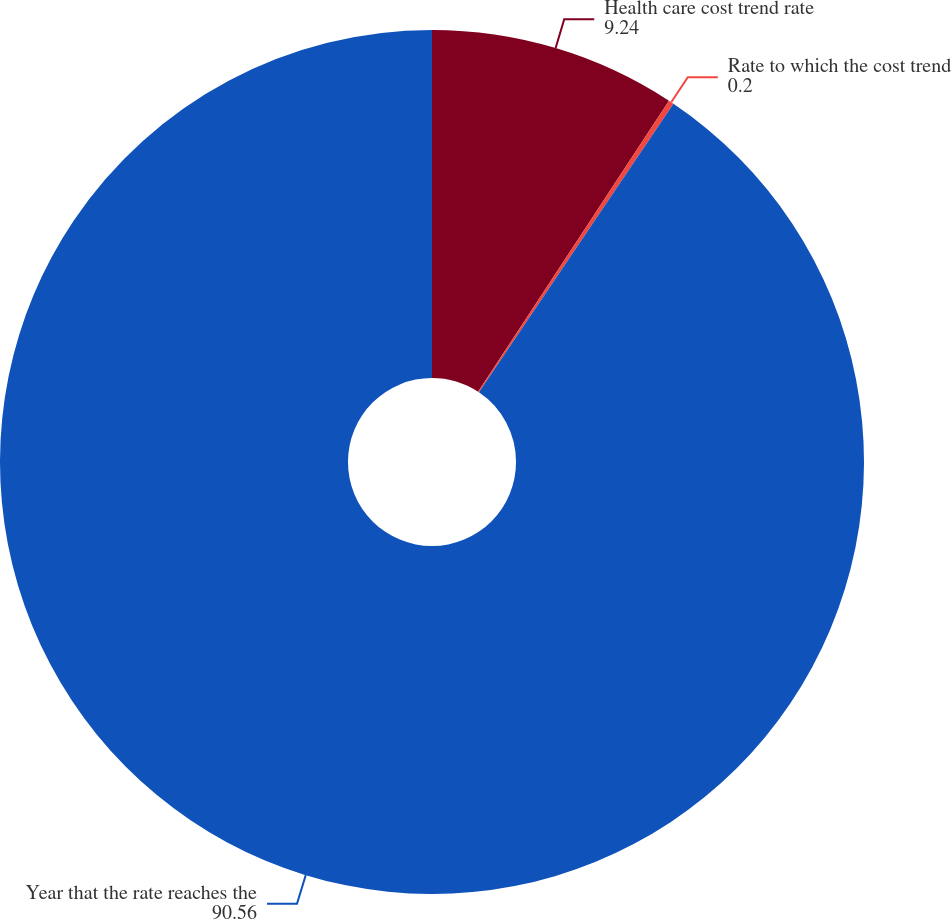Convert chart. <chart><loc_0><loc_0><loc_500><loc_500><pie_chart><fcel>Health care cost trend rate<fcel>Rate to which the cost trend<fcel>Year that the rate reaches the<nl><fcel>9.24%<fcel>0.2%<fcel>90.56%<nl></chart> 